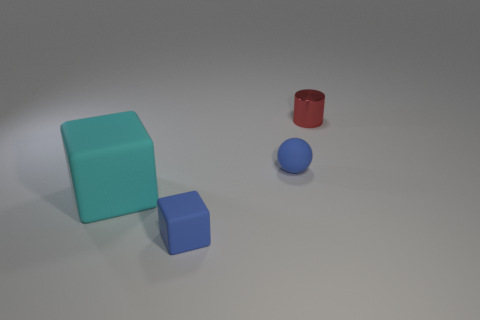Add 4 yellow shiny cylinders. How many objects exist? 8 Subtract all cylinders. How many objects are left? 3 Add 1 small blue objects. How many small blue objects are left? 3 Add 4 red objects. How many red objects exist? 5 Subtract 0 brown cubes. How many objects are left? 4 Subtract all cyan cubes. Subtract all tiny blue rubber spheres. How many objects are left? 2 